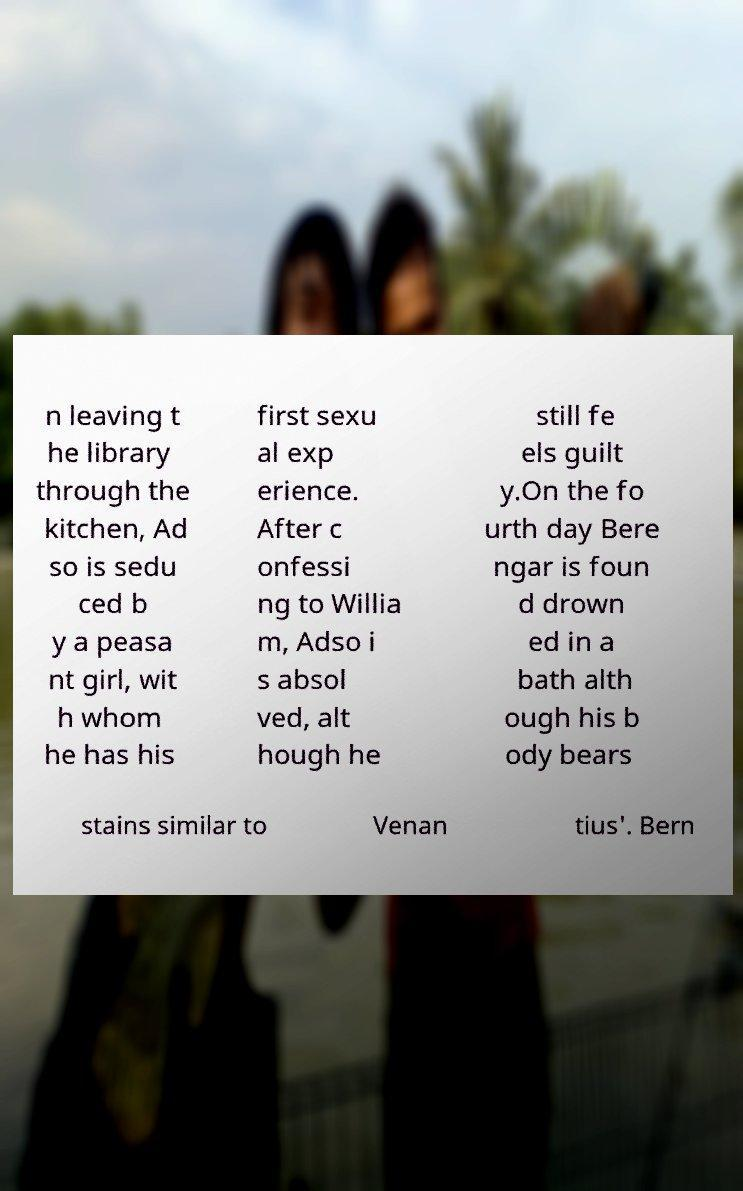Can you accurately transcribe the text from the provided image for me? n leaving t he library through the kitchen, Ad so is sedu ced b y a peasa nt girl, wit h whom he has his first sexu al exp erience. After c onfessi ng to Willia m, Adso i s absol ved, alt hough he still fe els guilt y.On the fo urth day Bere ngar is foun d drown ed in a bath alth ough his b ody bears stains similar to Venan tius'. Bern 